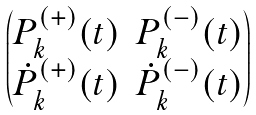Convert formula to latex. <formula><loc_0><loc_0><loc_500><loc_500>\begin{pmatrix} P _ { k } ^ { ( + ) } ( t ) & P _ { k } ^ { ( - ) } ( t ) \\ \dot { P } _ { k } ^ { ( + ) } ( t ) & \dot { P } _ { k } ^ { ( - ) } ( t ) \end{pmatrix}</formula> 